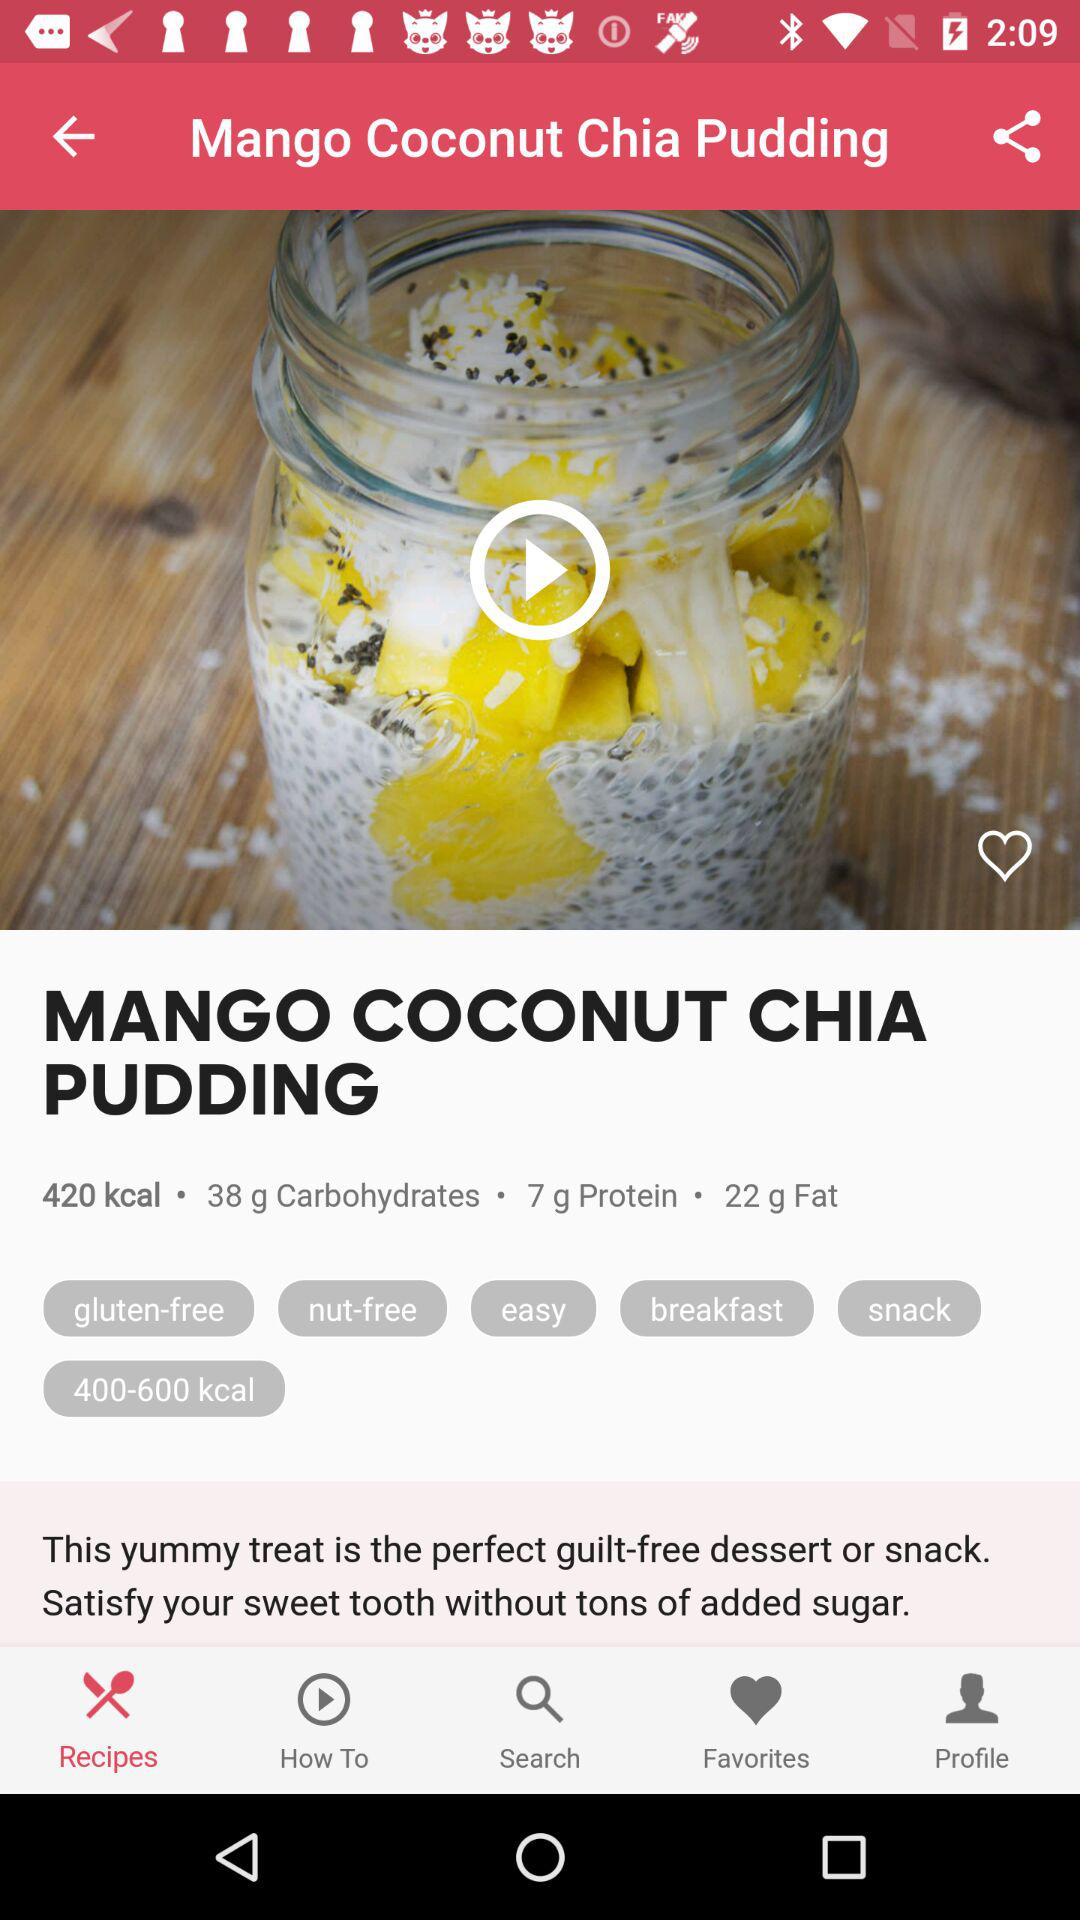How can I serve this pudding to make it even more special? To elevate this pudding, consider garnishing it with a sprinkle of toasted coconut flakes, a few fresh mango pieces, and a drizzle of honey or maple syrup. You could also add a dollop of Greek yogurt or a scoop of vanilla protein powder to increase the protein content for an even more fulfilling meal or snack. 